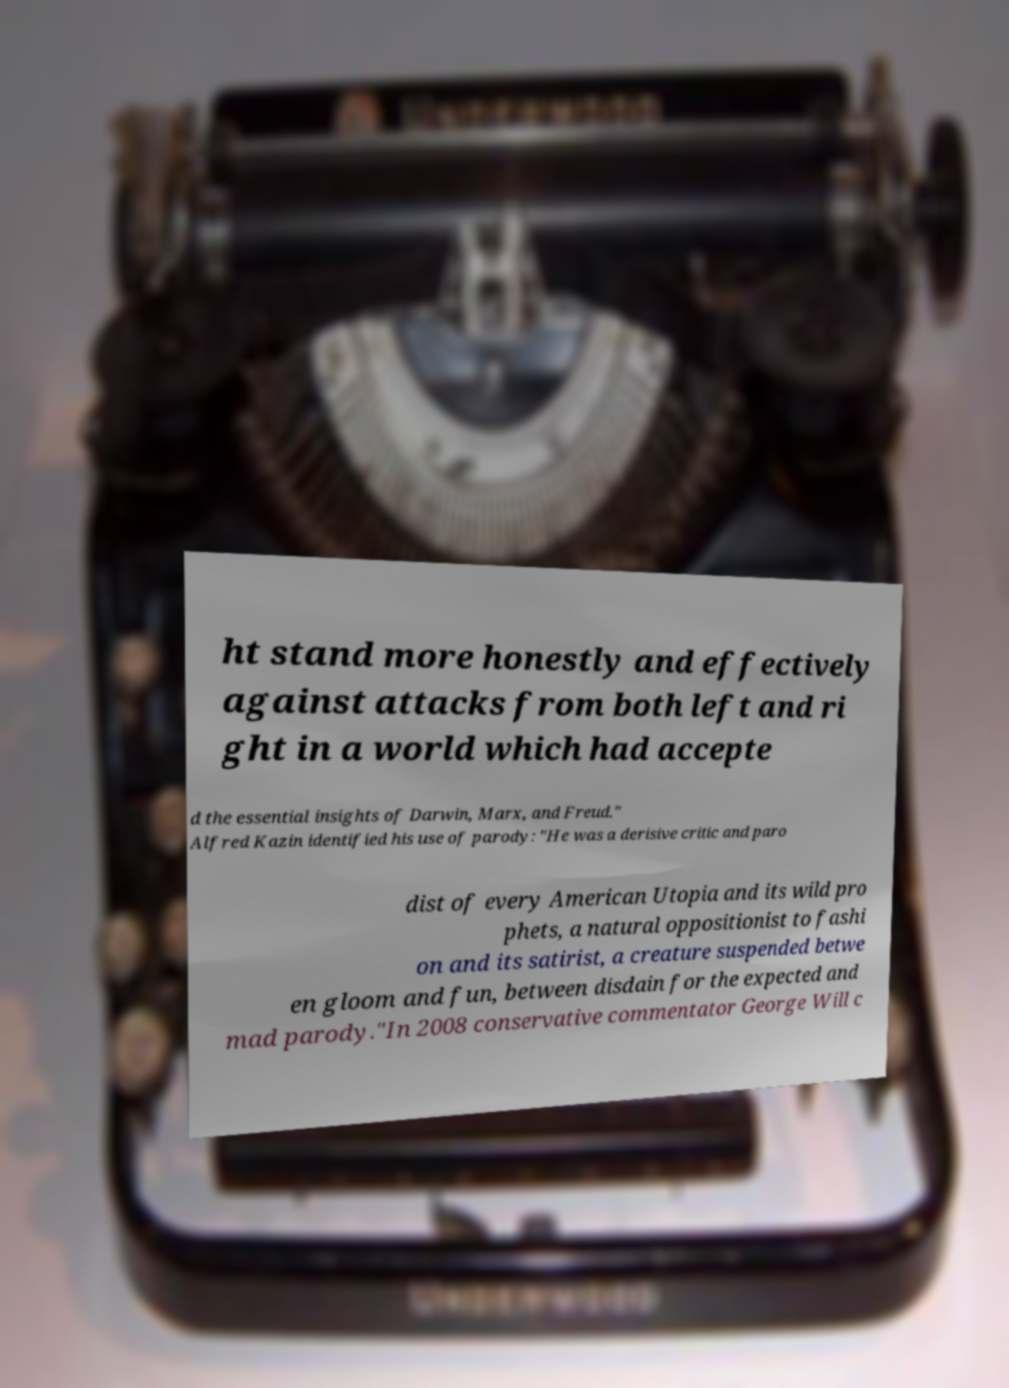I need the written content from this picture converted into text. Can you do that? ht stand more honestly and effectively against attacks from both left and ri ght in a world which had accepte d the essential insights of Darwin, Marx, and Freud." Alfred Kazin identified his use of parody: "He was a derisive critic and paro dist of every American Utopia and its wild pro phets, a natural oppositionist to fashi on and its satirist, a creature suspended betwe en gloom and fun, between disdain for the expected and mad parody."In 2008 conservative commentator George Will c 